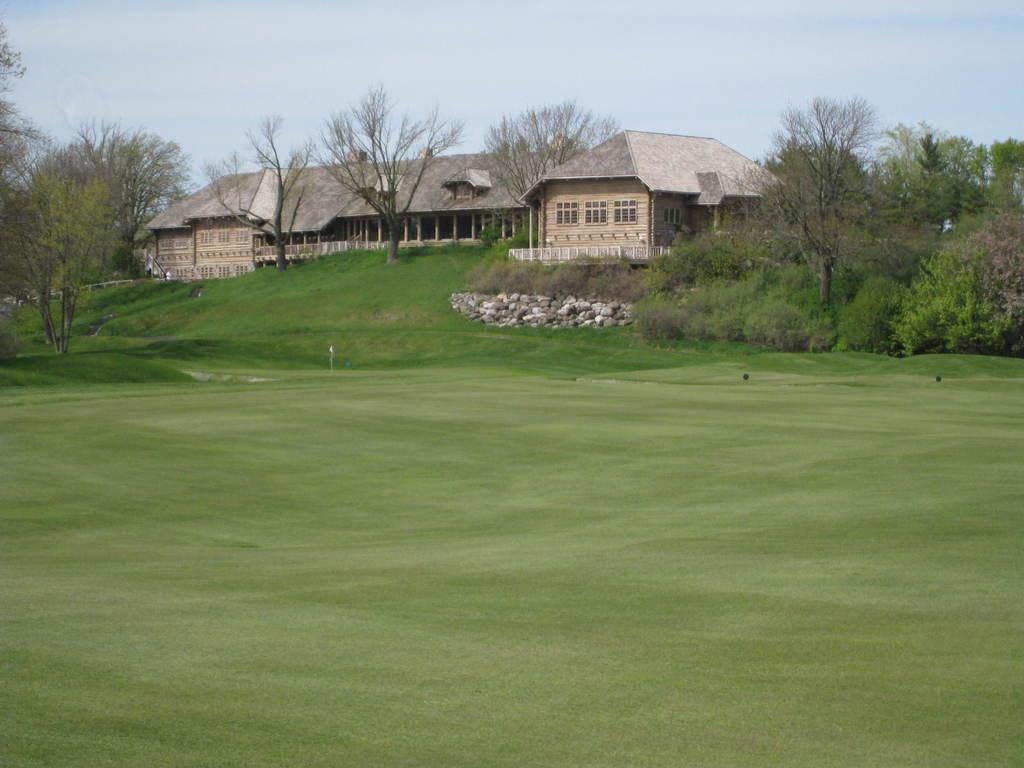What type of structures can be seen in the image? There are houses in the image. What feature is common to the houses and other objects in the image? There are windows visible in the image. What type of natural elements are present in the image? There are trees and rocks in the image. What is the color of the sky in the image? The sky is blue and white in color. Can you see a knife being used to cut the trees in the image? There is no knife or tree-cutting activity depicted in the image. What sign is present on the edge of the image? There is no sign present in the image, and the concept of an "edge" of the image is not relevant to the content of the image. 